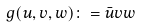<formula> <loc_0><loc_0><loc_500><loc_500>g ( u , v , w ) \colon = \bar { u } v w \,</formula> 